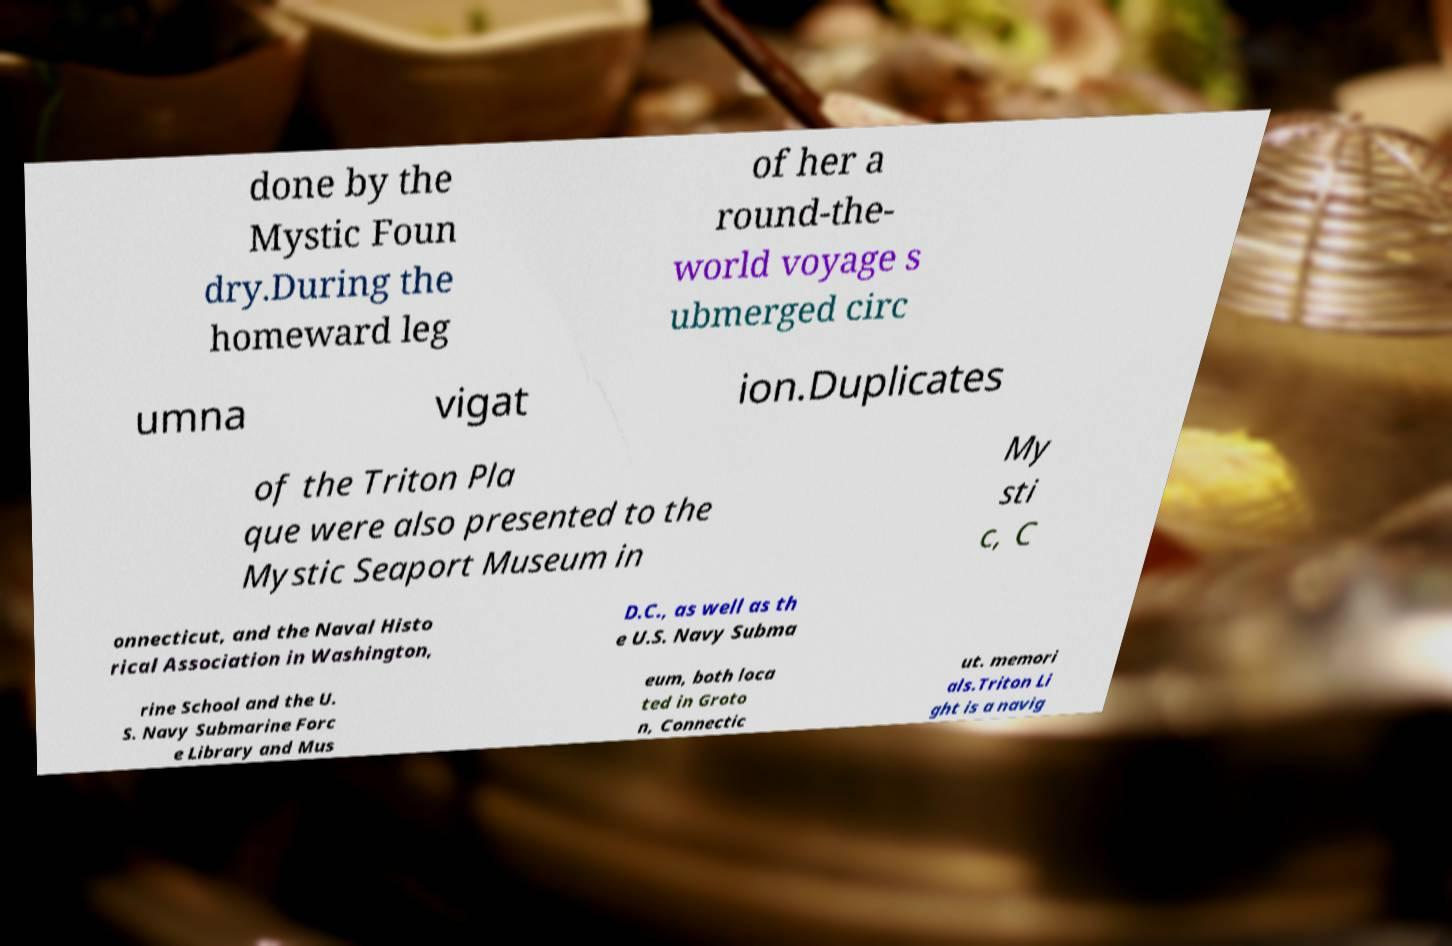Please read and relay the text visible in this image. What does it say? done by the Mystic Foun dry.During the homeward leg of her a round-the- world voyage s ubmerged circ umna vigat ion.Duplicates of the Triton Pla que were also presented to the Mystic Seaport Museum in My sti c, C onnecticut, and the Naval Histo rical Association in Washington, D.C., as well as th e U.S. Navy Subma rine School and the U. S. Navy Submarine Forc e Library and Mus eum, both loca ted in Groto n, Connectic ut. memori als.Triton Li ght is a navig 